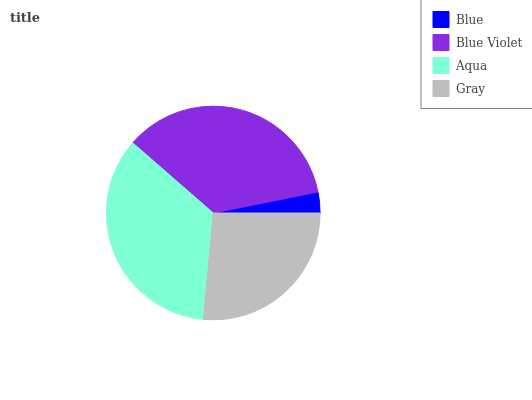Is Blue the minimum?
Answer yes or no. Yes. Is Blue Violet the maximum?
Answer yes or no. Yes. Is Aqua the minimum?
Answer yes or no. No. Is Aqua the maximum?
Answer yes or no. No. Is Blue Violet greater than Aqua?
Answer yes or no. Yes. Is Aqua less than Blue Violet?
Answer yes or no. Yes. Is Aqua greater than Blue Violet?
Answer yes or no. No. Is Blue Violet less than Aqua?
Answer yes or no. No. Is Aqua the high median?
Answer yes or no. Yes. Is Gray the low median?
Answer yes or no. Yes. Is Gray the high median?
Answer yes or no. No. Is Blue the low median?
Answer yes or no. No. 